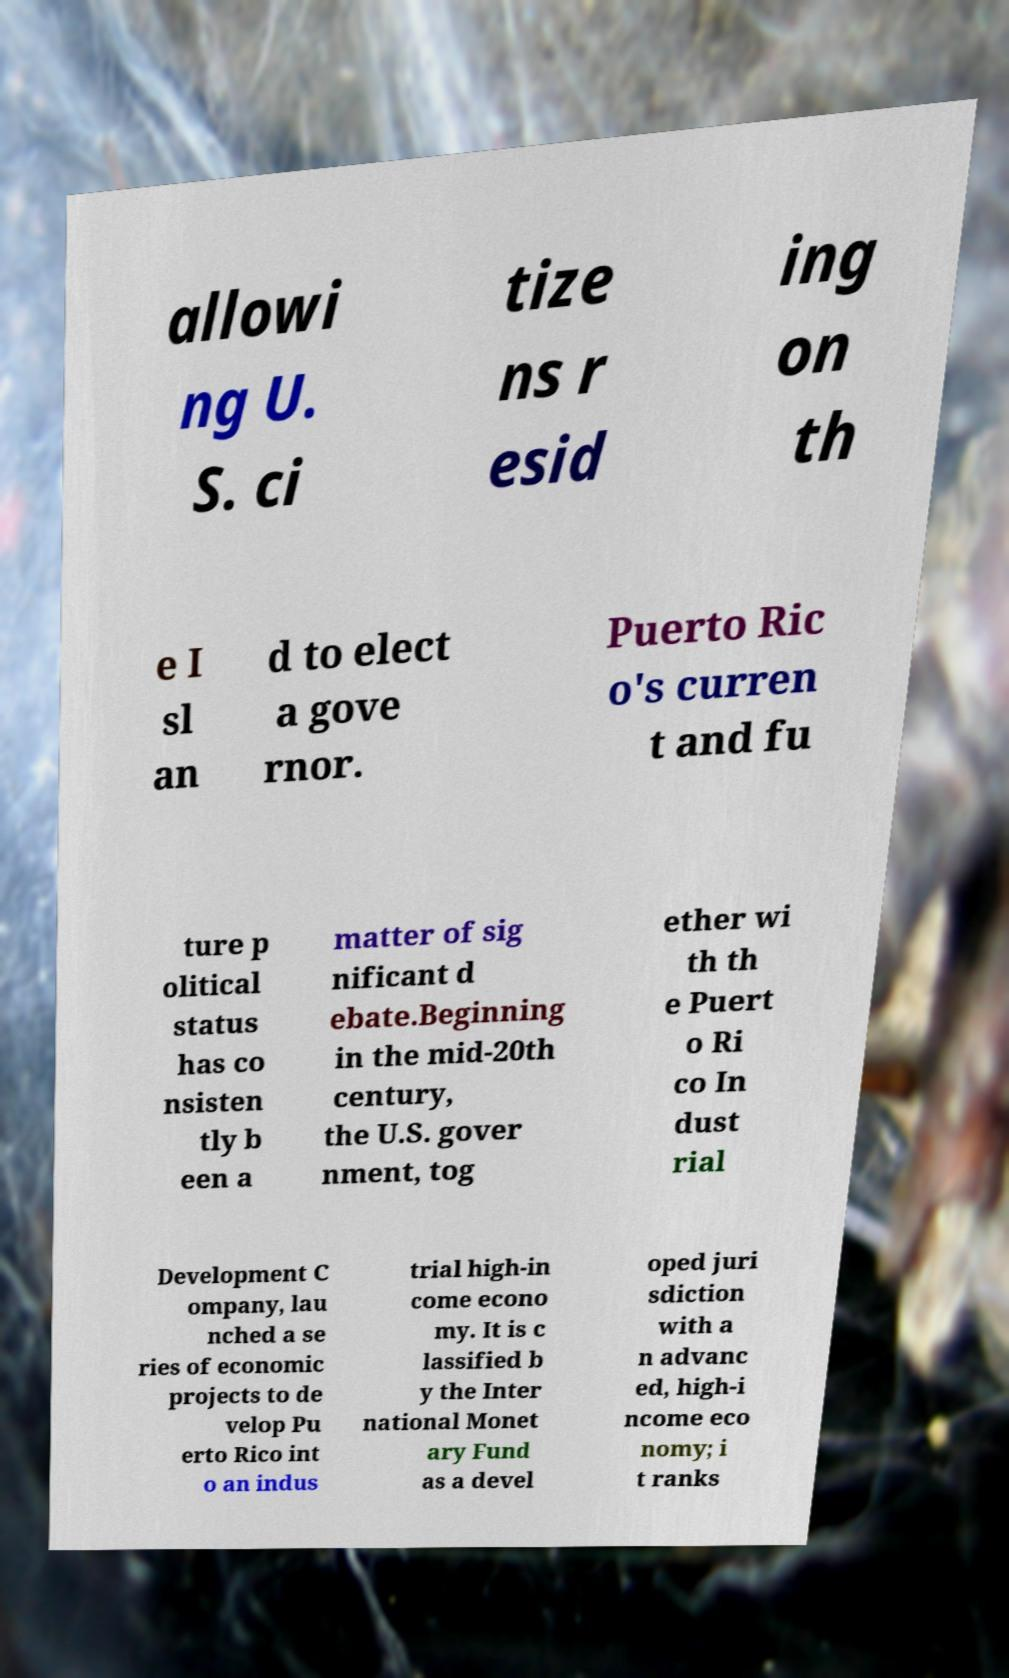Please read and relay the text visible in this image. What does it say? allowi ng U. S. ci tize ns r esid ing on th e I sl an d to elect a gove rnor. Puerto Ric o's curren t and fu ture p olitical status has co nsisten tly b een a matter of sig nificant d ebate.Beginning in the mid-20th century, the U.S. gover nment, tog ether wi th th e Puert o Ri co In dust rial Development C ompany, lau nched a se ries of economic projects to de velop Pu erto Rico int o an indus trial high-in come econo my. It is c lassified b y the Inter national Monet ary Fund as a devel oped juri sdiction with a n advanc ed, high-i ncome eco nomy; i t ranks 